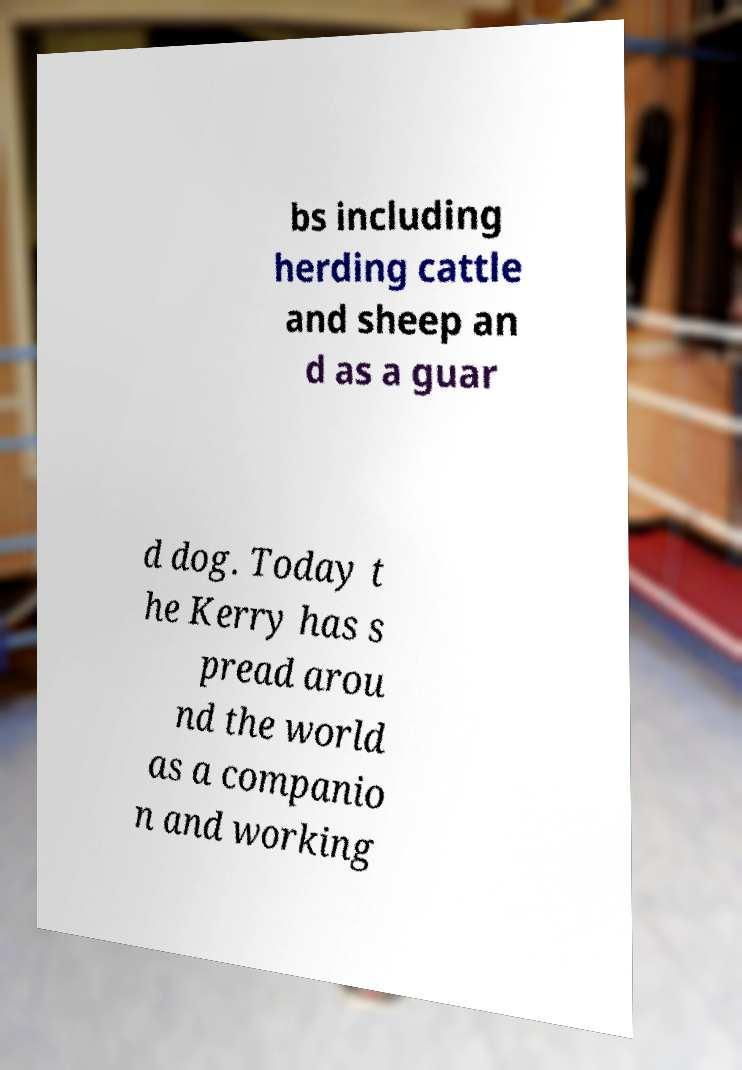Could you extract and type out the text from this image? bs including herding cattle and sheep an d as a guar d dog. Today t he Kerry has s pread arou nd the world as a companio n and working 